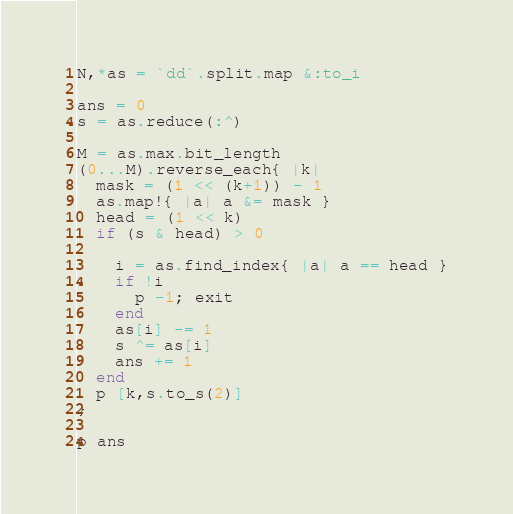<code> <loc_0><loc_0><loc_500><loc_500><_Ruby_>N,*as = `dd`.split.map &:to_i

ans = 0
s = as.reduce(:^)

M = as.max.bit_length
(0...M).reverse_each{ |k|
  mask = (1 << (k+1)) - 1
  as.map!{ |a| a &= mask }
  head = (1 << k)
  if (s & head) > 0 

    i = as.find_index{ |a| a == head }
    if !i 
      p -1; exit
    end
    as[i] -= 1
    s ^= as[i]
    ans += 1
  end
  p [k,s.to_s(2)]
}

p ans
</code> 